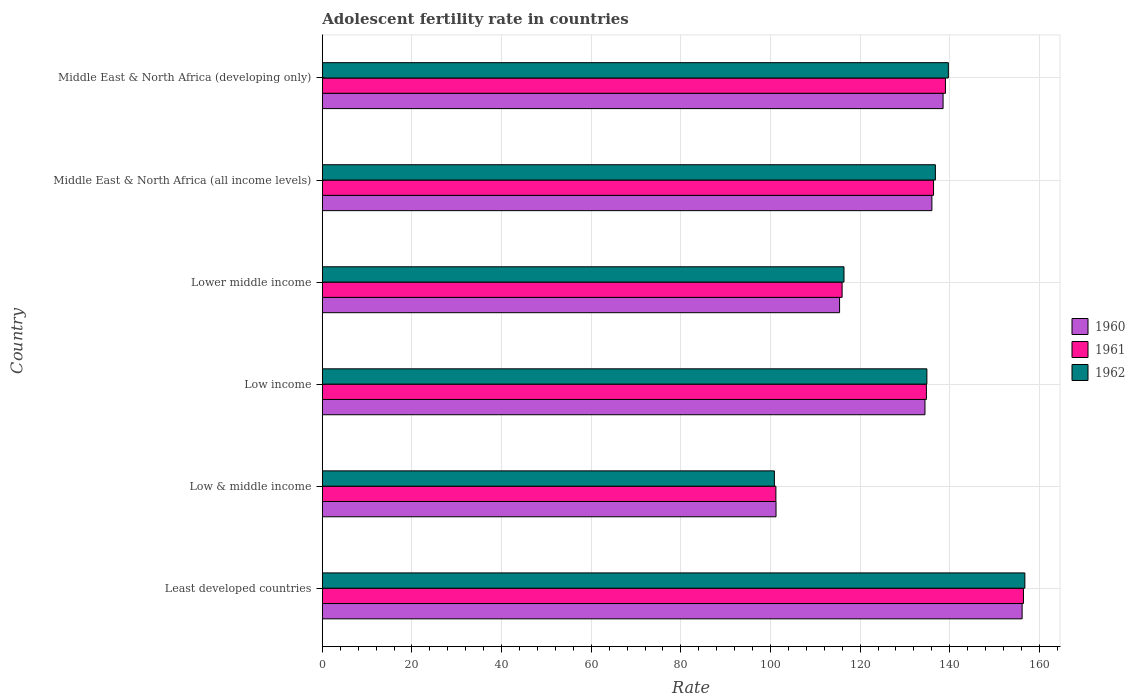How many different coloured bars are there?
Your response must be concise. 3. How many groups of bars are there?
Provide a succinct answer. 6. Are the number of bars per tick equal to the number of legend labels?
Give a very brief answer. Yes. Are the number of bars on each tick of the Y-axis equal?
Your answer should be very brief. Yes. What is the label of the 2nd group of bars from the top?
Provide a succinct answer. Middle East & North Africa (all income levels). What is the adolescent fertility rate in 1961 in Middle East & North Africa (developing only)?
Offer a very short reply. 139.04. Across all countries, what is the maximum adolescent fertility rate in 1961?
Your answer should be compact. 156.45. Across all countries, what is the minimum adolescent fertility rate in 1960?
Ensure brevity in your answer.  101.24. In which country was the adolescent fertility rate in 1962 maximum?
Make the answer very short. Least developed countries. What is the total adolescent fertility rate in 1962 in the graph?
Give a very brief answer. 785.41. What is the difference between the adolescent fertility rate in 1962 in Low & middle income and that in Low income?
Offer a terse response. -34.03. What is the difference between the adolescent fertility rate in 1961 in Middle East & North Africa (developing only) and the adolescent fertility rate in 1962 in Low income?
Keep it short and to the point. 4.15. What is the average adolescent fertility rate in 1961 per country?
Offer a very short reply. 130.64. What is the difference between the adolescent fertility rate in 1961 and adolescent fertility rate in 1960 in Lower middle income?
Offer a very short reply. 0.57. What is the ratio of the adolescent fertility rate in 1961 in Low & middle income to that in Middle East & North Africa (all income levels)?
Offer a very short reply. 0.74. What is the difference between the highest and the second highest adolescent fertility rate in 1962?
Your answer should be compact. 17.07. What is the difference between the highest and the lowest adolescent fertility rate in 1961?
Ensure brevity in your answer.  55.24. Is the sum of the adolescent fertility rate in 1961 in Low & middle income and Middle East & North Africa (developing only) greater than the maximum adolescent fertility rate in 1962 across all countries?
Offer a terse response. Yes. Is it the case that in every country, the sum of the adolescent fertility rate in 1962 and adolescent fertility rate in 1960 is greater than the adolescent fertility rate in 1961?
Ensure brevity in your answer.  Yes. Are all the bars in the graph horizontal?
Provide a short and direct response. Yes. What is the difference between two consecutive major ticks on the X-axis?
Offer a very short reply. 20. Does the graph contain grids?
Ensure brevity in your answer.  Yes. Where does the legend appear in the graph?
Your answer should be compact. Center right. How many legend labels are there?
Make the answer very short. 3. What is the title of the graph?
Offer a terse response. Adolescent fertility rate in countries. Does "1983" appear as one of the legend labels in the graph?
Keep it short and to the point. No. What is the label or title of the X-axis?
Your answer should be very brief. Rate. What is the label or title of the Y-axis?
Keep it short and to the point. Country. What is the Rate in 1960 in Least developed countries?
Keep it short and to the point. 156.15. What is the Rate of 1961 in Least developed countries?
Offer a very short reply. 156.45. What is the Rate in 1962 in Least developed countries?
Your response must be concise. 156.76. What is the Rate in 1960 in Low & middle income?
Make the answer very short. 101.24. What is the Rate in 1961 in Low & middle income?
Your answer should be very brief. 101.21. What is the Rate in 1962 in Low & middle income?
Your answer should be compact. 100.87. What is the Rate of 1960 in Low income?
Provide a short and direct response. 134.47. What is the Rate in 1961 in Low income?
Offer a very short reply. 134.79. What is the Rate in 1962 in Low income?
Keep it short and to the point. 134.9. What is the Rate in 1960 in Lower middle income?
Make the answer very short. 115.42. What is the Rate of 1961 in Lower middle income?
Give a very brief answer. 115.98. What is the Rate in 1962 in Lower middle income?
Ensure brevity in your answer.  116.4. What is the Rate of 1960 in Middle East & North Africa (all income levels)?
Make the answer very short. 136.02. What is the Rate of 1961 in Middle East & North Africa (all income levels)?
Give a very brief answer. 136.38. What is the Rate in 1962 in Middle East & North Africa (all income levels)?
Give a very brief answer. 136.79. What is the Rate of 1960 in Middle East & North Africa (developing only)?
Your answer should be very brief. 138.51. What is the Rate in 1961 in Middle East & North Africa (developing only)?
Your answer should be compact. 139.04. What is the Rate in 1962 in Middle East & North Africa (developing only)?
Keep it short and to the point. 139.69. Across all countries, what is the maximum Rate in 1960?
Ensure brevity in your answer.  156.15. Across all countries, what is the maximum Rate of 1961?
Your answer should be compact. 156.45. Across all countries, what is the maximum Rate in 1962?
Your answer should be very brief. 156.76. Across all countries, what is the minimum Rate of 1960?
Your answer should be very brief. 101.24. Across all countries, what is the minimum Rate in 1961?
Give a very brief answer. 101.21. Across all countries, what is the minimum Rate in 1962?
Keep it short and to the point. 100.87. What is the total Rate in 1960 in the graph?
Ensure brevity in your answer.  781.8. What is the total Rate in 1961 in the graph?
Your answer should be very brief. 783.86. What is the total Rate of 1962 in the graph?
Provide a succinct answer. 785.41. What is the difference between the Rate in 1960 in Least developed countries and that in Low & middle income?
Provide a short and direct response. 54.91. What is the difference between the Rate of 1961 in Least developed countries and that in Low & middle income?
Offer a terse response. 55.24. What is the difference between the Rate of 1962 in Least developed countries and that in Low & middle income?
Provide a short and direct response. 55.89. What is the difference between the Rate of 1960 in Least developed countries and that in Low income?
Offer a very short reply. 21.68. What is the difference between the Rate of 1961 in Least developed countries and that in Low income?
Offer a very short reply. 21.66. What is the difference between the Rate of 1962 in Least developed countries and that in Low income?
Your answer should be very brief. 21.87. What is the difference between the Rate of 1960 in Least developed countries and that in Lower middle income?
Your answer should be compact. 40.73. What is the difference between the Rate of 1961 in Least developed countries and that in Lower middle income?
Your answer should be very brief. 40.47. What is the difference between the Rate of 1962 in Least developed countries and that in Lower middle income?
Ensure brevity in your answer.  40.36. What is the difference between the Rate of 1960 in Least developed countries and that in Middle East & North Africa (all income levels)?
Provide a succinct answer. 20.13. What is the difference between the Rate of 1961 in Least developed countries and that in Middle East & North Africa (all income levels)?
Provide a succinct answer. 20.07. What is the difference between the Rate of 1962 in Least developed countries and that in Middle East & North Africa (all income levels)?
Your response must be concise. 19.97. What is the difference between the Rate of 1960 in Least developed countries and that in Middle East & North Africa (developing only)?
Provide a succinct answer. 17.64. What is the difference between the Rate of 1961 in Least developed countries and that in Middle East & North Africa (developing only)?
Give a very brief answer. 17.41. What is the difference between the Rate in 1962 in Least developed countries and that in Middle East & North Africa (developing only)?
Your answer should be compact. 17.07. What is the difference between the Rate of 1960 in Low & middle income and that in Low income?
Provide a short and direct response. -33.23. What is the difference between the Rate of 1961 in Low & middle income and that in Low income?
Offer a very short reply. -33.59. What is the difference between the Rate in 1962 in Low & middle income and that in Low income?
Provide a short and direct response. -34.03. What is the difference between the Rate in 1960 in Low & middle income and that in Lower middle income?
Your answer should be very brief. -14.18. What is the difference between the Rate in 1961 in Low & middle income and that in Lower middle income?
Provide a succinct answer. -14.78. What is the difference between the Rate of 1962 in Low & middle income and that in Lower middle income?
Offer a terse response. -15.53. What is the difference between the Rate of 1960 in Low & middle income and that in Middle East & North Africa (all income levels)?
Your answer should be very brief. -34.78. What is the difference between the Rate of 1961 in Low & middle income and that in Middle East & North Africa (all income levels)?
Give a very brief answer. -35.18. What is the difference between the Rate of 1962 in Low & middle income and that in Middle East & North Africa (all income levels)?
Your response must be concise. -35.92. What is the difference between the Rate of 1960 in Low & middle income and that in Middle East & North Africa (developing only)?
Provide a succinct answer. -37.27. What is the difference between the Rate of 1961 in Low & middle income and that in Middle East & North Africa (developing only)?
Make the answer very short. -37.84. What is the difference between the Rate of 1962 in Low & middle income and that in Middle East & North Africa (developing only)?
Your answer should be very brief. -38.82. What is the difference between the Rate in 1960 in Low income and that in Lower middle income?
Your answer should be very brief. 19.05. What is the difference between the Rate in 1961 in Low income and that in Lower middle income?
Ensure brevity in your answer.  18.81. What is the difference between the Rate in 1962 in Low income and that in Lower middle income?
Make the answer very short. 18.5. What is the difference between the Rate in 1960 in Low income and that in Middle East & North Africa (all income levels)?
Offer a terse response. -1.55. What is the difference between the Rate of 1961 in Low income and that in Middle East & North Africa (all income levels)?
Offer a very short reply. -1.59. What is the difference between the Rate of 1962 in Low income and that in Middle East & North Africa (all income levels)?
Your response must be concise. -1.9. What is the difference between the Rate of 1960 in Low income and that in Middle East & North Africa (developing only)?
Provide a succinct answer. -4.04. What is the difference between the Rate in 1961 in Low income and that in Middle East & North Africa (developing only)?
Your answer should be compact. -4.25. What is the difference between the Rate in 1962 in Low income and that in Middle East & North Africa (developing only)?
Offer a terse response. -4.79. What is the difference between the Rate of 1960 in Lower middle income and that in Middle East & North Africa (all income levels)?
Offer a very short reply. -20.6. What is the difference between the Rate of 1961 in Lower middle income and that in Middle East & North Africa (all income levels)?
Give a very brief answer. -20.4. What is the difference between the Rate of 1962 in Lower middle income and that in Middle East & North Africa (all income levels)?
Your answer should be compact. -20.39. What is the difference between the Rate of 1960 in Lower middle income and that in Middle East & North Africa (developing only)?
Make the answer very short. -23.09. What is the difference between the Rate in 1961 in Lower middle income and that in Middle East & North Africa (developing only)?
Your response must be concise. -23.06. What is the difference between the Rate in 1962 in Lower middle income and that in Middle East & North Africa (developing only)?
Provide a short and direct response. -23.29. What is the difference between the Rate of 1960 in Middle East & North Africa (all income levels) and that in Middle East & North Africa (developing only)?
Your answer should be compact. -2.49. What is the difference between the Rate in 1961 in Middle East & North Africa (all income levels) and that in Middle East & North Africa (developing only)?
Your answer should be very brief. -2.66. What is the difference between the Rate in 1962 in Middle East & North Africa (all income levels) and that in Middle East & North Africa (developing only)?
Your answer should be very brief. -2.9. What is the difference between the Rate in 1960 in Least developed countries and the Rate in 1961 in Low & middle income?
Offer a very short reply. 54.94. What is the difference between the Rate of 1960 in Least developed countries and the Rate of 1962 in Low & middle income?
Your response must be concise. 55.28. What is the difference between the Rate in 1961 in Least developed countries and the Rate in 1962 in Low & middle income?
Make the answer very short. 55.58. What is the difference between the Rate in 1960 in Least developed countries and the Rate in 1961 in Low income?
Provide a succinct answer. 21.36. What is the difference between the Rate in 1960 in Least developed countries and the Rate in 1962 in Low income?
Provide a short and direct response. 21.25. What is the difference between the Rate of 1961 in Least developed countries and the Rate of 1962 in Low income?
Keep it short and to the point. 21.55. What is the difference between the Rate in 1960 in Least developed countries and the Rate in 1961 in Lower middle income?
Ensure brevity in your answer.  40.16. What is the difference between the Rate in 1960 in Least developed countries and the Rate in 1962 in Lower middle income?
Keep it short and to the point. 39.75. What is the difference between the Rate of 1961 in Least developed countries and the Rate of 1962 in Lower middle income?
Your response must be concise. 40.05. What is the difference between the Rate in 1960 in Least developed countries and the Rate in 1961 in Middle East & North Africa (all income levels)?
Provide a succinct answer. 19.76. What is the difference between the Rate in 1960 in Least developed countries and the Rate in 1962 in Middle East & North Africa (all income levels)?
Your response must be concise. 19.36. What is the difference between the Rate in 1961 in Least developed countries and the Rate in 1962 in Middle East & North Africa (all income levels)?
Keep it short and to the point. 19.66. What is the difference between the Rate in 1960 in Least developed countries and the Rate in 1961 in Middle East & North Africa (developing only)?
Provide a succinct answer. 17.11. What is the difference between the Rate in 1960 in Least developed countries and the Rate in 1962 in Middle East & North Africa (developing only)?
Provide a short and direct response. 16.46. What is the difference between the Rate in 1961 in Least developed countries and the Rate in 1962 in Middle East & North Africa (developing only)?
Offer a very short reply. 16.76. What is the difference between the Rate of 1960 in Low & middle income and the Rate of 1961 in Low income?
Keep it short and to the point. -33.55. What is the difference between the Rate of 1960 in Low & middle income and the Rate of 1962 in Low income?
Your response must be concise. -33.66. What is the difference between the Rate in 1961 in Low & middle income and the Rate in 1962 in Low income?
Keep it short and to the point. -33.69. What is the difference between the Rate in 1960 in Low & middle income and the Rate in 1961 in Lower middle income?
Give a very brief answer. -14.75. What is the difference between the Rate of 1960 in Low & middle income and the Rate of 1962 in Lower middle income?
Offer a very short reply. -15.16. What is the difference between the Rate of 1961 in Low & middle income and the Rate of 1962 in Lower middle income?
Keep it short and to the point. -15.19. What is the difference between the Rate in 1960 in Low & middle income and the Rate in 1961 in Middle East & North Africa (all income levels)?
Provide a succinct answer. -35.15. What is the difference between the Rate of 1960 in Low & middle income and the Rate of 1962 in Middle East & North Africa (all income levels)?
Your answer should be very brief. -35.55. What is the difference between the Rate of 1961 in Low & middle income and the Rate of 1962 in Middle East & North Africa (all income levels)?
Offer a very short reply. -35.59. What is the difference between the Rate of 1960 in Low & middle income and the Rate of 1961 in Middle East & North Africa (developing only)?
Your response must be concise. -37.8. What is the difference between the Rate in 1960 in Low & middle income and the Rate in 1962 in Middle East & North Africa (developing only)?
Give a very brief answer. -38.45. What is the difference between the Rate of 1961 in Low & middle income and the Rate of 1962 in Middle East & North Africa (developing only)?
Offer a terse response. -38.48. What is the difference between the Rate in 1960 in Low income and the Rate in 1961 in Lower middle income?
Offer a terse response. 18.49. What is the difference between the Rate in 1960 in Low income and the Rate in 1962 in Lower middle income?
Ensure brevity in your answer.  18.07. What is the difference between the Rate in 1961 in Low income and the Rate in 1962 in Lower middle income?
Your answer should be compact. 18.39. What is the difference between the Rate in 1960 in Low income and the Rate in 1961 in Middle East & North Africa (all income levels)?
Offer a very short reply. -1.91. What is the difference between the Rate of 1960 in Low income and the Rate of 1962 in Middle East & North Africa (all income levels)?
Provide a short and direct response. -2.32. What is the difference between the Rate in 1961 in Low income and the Rate in 1962 in Middle East & North Africa (all income levels)?
Your response must be concise. -2. What is the difference between the Rate of 1960 in Low income and the Rate of 1961 in Middle East & North Africa (developing only)?
Your response must be concise. -4.57. What is the difference between the Rate of 1960 in Low income and the Rate of 1962 in Middle East & North Africa (developing only)?
Keep it short and to the point. -5.22. What is the difference between the Rate in 1961 in Low income and the Rate in 1962 in Middle East & North Africa (developing only)?
Make the answer very short. -4.9. What is the difference between the Rate of 1960 in Lower middle income and the Rate of 1961 in Middle East & North Africa (all income levels)?
Provide a succinct answer. -20.97. What is the difference between the Rate of 1960 in Lower middle income and the Rate of 1962 in Middle East & North Africa (all income levels)?
Make the answer very short. -21.37. What is the difference between the Rate of 1961 in Lower middle income and the Rate of 1962 in Middle East & North Africa (all income levels)?
Your answer should be very brief. -20.81. What is the difference between the Rate in 1960 in Lower middle income and the Rate in 1961 in Middle East & North Africa (developing only)?
Offer a terse response. -23.62. What is the difference between the Rate of 1960 in Lower middle income and the Rate of 1962 in Middle East & North Africa (developing only)?
Ensure brevity in your answer.  -24.27. What is the difference between the Rate in 1961 in Lower middle income and the Rate in 1962 in Middle East & North Africa (developing only)?
Provide a short and direct response. -23.7. What is the difference between the Rate of 1960 in Middle East & North Africa (all income levels) and the Rate of 1961 in Middle East & North Africa (developing only)?
Your answer should be very brief. -3.03. What is the difference between the Rate in 1960 in Middle East & North Africa (all income levels) and the Rate in 1962 in Middle East & North Africa (developing only)?
Offer a terse response. -3.67. What is the difference between the Rate in 1961 in Middle East & North Africa (all income levels) and the Rate in 1962 in Middle East & North Africa (developing only)?
Offer a terse response. -3.3. What is the average Rate of 1960 per country?
Provide a succinct answer. 130.3. What is the average Rate in 1961 per country?
Offer a very short reply. 130.64. What is the average Rate in 1962 per country?
Give a very brief answer. 130.9. What is the difference between the Rate of 1960 and Rate of 1961 in Least developed countries?
Your answer should be compact. -0.3. What is the difference between the Rate of 1960 and Rate of 1962 in Least developed countries?
Provide a short and direct response. -0.61. What is the difference between the Rate of 1961 and Rate of 1962 in Least developed countries?
Offer a terse response. -0.31. What is the difference between the Rate of 1960 and Rate of 1961 in Low & middle income?
Provide a short and direct response. 0.03. What is the difference between the Rate of 1960 and Rate of 1962 in Low & middle income?
Give a very brief answer. 0.37. What is the difference between the Rate of 1961 and Rate of 1962 in Low & middle income?
Your response must be concise. 0.34. What is the difference between the Rate in 1960 and Rate in 1961 in Low income?
Offer a very short reply. -0.32. What is the difference between the Rate in 1960 and Rate in 1962 in Low income?
Your answer should be compact. -0.43. What is the difference between the Rate of 1961 and Rate of 1962 in Low income?
Provide a short and direct response. -0.1. What is the difference between the Rate in 1960 and Rate in 1961 in Lower middle income?
Your answer should be very brief. -0.57. What is the difference between the Rate in 1960 and Rate in 1962 in Lower middle income?
Your answer should be very brief. -0.98. What is the difference between the Rate of 1961 and Rate of 1962 in Lower middle income?
Keep it short and to the point. -0.42. What is the difference between the Rate in 1960 and Rate in 1961 in Middle East & North Africa (all income levels)?
Keep it short and to the point. -0.37. What is the difference between the Rate in 1960 and Rate in 1962 in Middle East & North Africa (all income levels)?
Your response must be concise. -0.78. What is the difference between the Rate in 1961 and Rate in 1962 in Middle East & North Africa (all income levels)?
Offer a terse response. -0.41. What is the difference between the Rate in 1960 and Rate in 1961 in Middle East & North Africa (developing only)?
Offer a very short reply. -0.53. What is the difference between the Rate in 1960 and Rate in 1962 in Middle East & North Africa (developing only)?
Provide a succinct answer. -1.18. What is the difference between the Rate in 1961 and Rate in 1962 in Middle East & North Africa (developing only)?
Offer a terse response. -0.65. What is the ratio of the Rate in 1960 in Least developed countries to that in Low & middle income?
Your answer should be compact. 1.54. What is the ratio of the Rate of 1961 in Least developed countries to that in Low & middle income?
Offer a terse response. 1.55. What is the ratio of the Rate in 1962 in Least developed countries to that in Low & middle income?
Your answer should be compact. 1.55. What is the ratio of the Rate of 1960 in Least developed countries to that in Low income?
Give a very brief answer. 1.16. What is the ratio of the Rate in 1961 in Least developed countries to that in Low income?
Give a very brief answer. 1.16. What is the ratio of the Rate in 1962 in Least developed countries to that in Low income?
Ensure brevity in your answer.  1.16. What is the ratio of the Rate of 1960 in Least developed countries to that in Lower middle income?
Offer a very short reply. 1.35. What is the ratio of the Rate of 1961 in Least developed countries to that in Lower middle income?
Offer a terse response. 1.35. What is the ratio of the Rate of 1962 in Least developed countries to that in Lower middle income?
Make the answer very short. 1.35. What is the ratio of the Rate of 1960 in Least developed countries to that in Middle East & North Africa (all income levels)?
Ensure brevity in your answer.  1.15. What is the ratio of the Rate of 1961 in Least developed countries to that in Middle East & North Africa (all income levels)?
Offer a terse response. 1.15. What is the ratio of the Rate of 1962 in Least developed countries to that in Middle East & North Africa (all income levels)?
Offer a terse response. 1.15. What is the ratio of the Rate of 1960 in Least developed countries to that in Middle East & North Africa (developing only)?
Provide a short and direct response. 1.13. What is the ratio of the Rate in 1961 in Least developed countries to that in Middle East & North Africa (developing only)?
Your response must be concise. 1.13. What is the ratio of the Rate of 1962 in Least developed countries to that in Middle East & North Africa (developing only)?
Your answer should be very brief. 1.12. What is the ratio of the Rate in 1960 in Low & middle income to that in Low income?
Offer a very short reply. 0.75. What is the ratio of the Rate in 1961 in Low & middle income to that in Low income?
Make the answer very short. 0.75. What is the ratio of the Rate of 1962 in Low & middle income to that in Low income?
Your answer should be compact. 0.75. What is the ratio of the Rate of 1960 in Low & middle income to that in Lower middle income?
Provide a short and direct response. 0.88. What is the ratio of the Rate in 1961 in Low & middle income to that in Lower middle income?
Your answer should be very brief. 0.87. What is the ratio of the Rate of 1962 in Low & middle income to that in Lower middle income?
Offer a very short reply. 0.87. What is the ratio of the Rate of 1960 in Low & middle income to that in Middle East & North Africa (all income levels)?
Provide a succinct answer. 0.74. What is the ratio of the Rate of 1961 in Low & middle income to that in Middle East & North Africa (all income levels)?
Provide a short and direct response. 0.74. What is the ratio of the Rate of 1962 in Low & middle income to that in Middle East & North Africa (all income levels)?
Keep it short and to the point. 0.74. What is the ratio of the Rate of 1960 in Low & middle income to that in Middle East & North Africa (developing only)?
Give a very brief answer. 0.73. What is the ratio of the Rate in 1961 in Low & middle income to that in Middle East & North Africa (developing only)?
Give a very brief answer. 0.73. What is the ratio of the Rate in 1962 in Low & middle income to that in Middle East & North Africa (developing only)?
Make the answer very short. 0.72. What is the ratio of the Rate in 1960 in Low income to that in Lower middle income?
Offer a very short reply. 1.17. What is the ratio of the Rate of 1961 in Low income to that in Lower middle income?
Your answer should be compact. 1.16. What is the ratio of the Rate in 1962 in Low income to that in Lower middle income?
Your answer should be compact. 1.16. What is the ratio of the Rate in 1960 in Low income to that in Middle East & North Africa (all income levels)?
Make the answer very short. 0.99. What is the ratio of the Rate in 1961 in Low income to that in Middle East & North Africa (all income levels)?
Give a very brief answer. 0.99. What is the ratio of the Rate in 1962 in Low income to that in Middle East & North Africa (all income levels)?
Offer a very short reply. 0.99. What is the ratio of the Rate of 1960 in Low income to that in Middle East & North Africa (developing only)?
Your answer should be compact. 0.97. What is the ratio of the Rate in 1961 in Low income to that in Middle East & North Africa (developing only)?
Provide a short and direct response. 0.97. What is the ratio of the Rate of 1962 in Low income to that in Middle East & North Africa (developing only)?
Ensure brevity in your answer.  0.97. What is the ratio of the Rate in 1960 in Lower middle income to that in Middle East & North Africa (all income levels)?
Provide a short and direct response. 0.85. What is the ratio of the Rate of 1961 in Lower middle income to that in Middle East & North Africa (all income levels)?
Your answer should be compact. 0.85. What is the ratio of the Rate in 1962 in Lower middle income to that in Middle East & North Africa (all income levels)?
Provide a succinct answer. 0.85. What is the ratio of the Rate of 1960 in Lower middle income to that in Middle East & North Africa (developing only)?
Provide a succinct answer. 0.83. What is the ratio of the Rate of 1961 in Lower middle income to that in Middle East & North Africa (developing only)?
Offer a very short reply. 0.83. What is the ratio of the Rate in 1962 in Lower middle income to that in Middle East & North Africa (developing only)?
Offer a very short reply. 0.83. What is the ratio of the Rate in 1961 in Middle East & North Africa (all income levels) to that in Middle East & North Africa (developing only)?
Offer a terse response. 0.98. What is the ratio of the Rate of 1962 in Middle East & North Africa (all income levels) to that in Middle East & North Africa (developing only)?
Offer a terse response. 0.98. What is the difference between the highest and the second highest Rate in 1960?
Ensure brevity in your answer.  17.64. What is the difference between the highest and the second highest Rate in 1961?
Your answer should be compact. 17.41. What is the difference between the highest and the second highest Rate of 1962?
Your answer should be very brief. 17.07. What is the difference between the highest and the lowest Rate in 1960?
Provide a short and direct response. 54.91. What is the difference between the highest and the lowest Rate in 1961?
Make the answer very short. 55.24. What is the difference between the highest and the lowest Rate in 1962?
Make the answer very short. 55.89. 